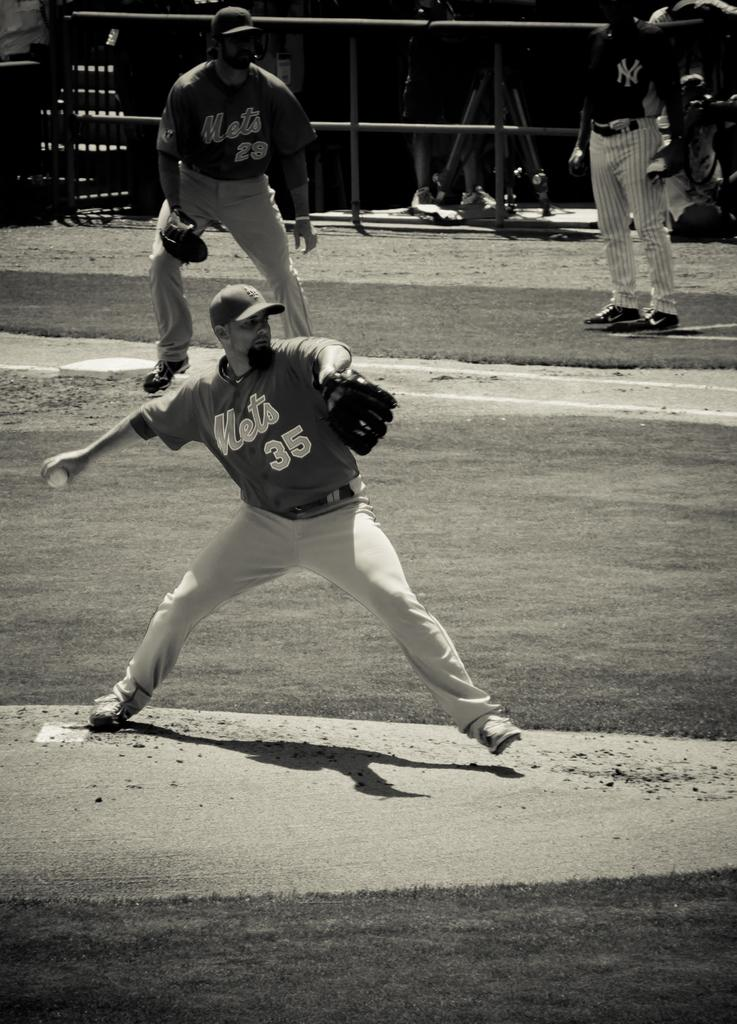What is the color scheme of the image? The image is black and white. How many people are standing in the image? There are three persons standing in the image. What is one person holding in the image? One person is holding a ball. Can you describe the background of the image? There are other persons and objects in the background of the image. What type of bread can be seen flying in the image? There is no bread present in the image, and no objects are flying. 